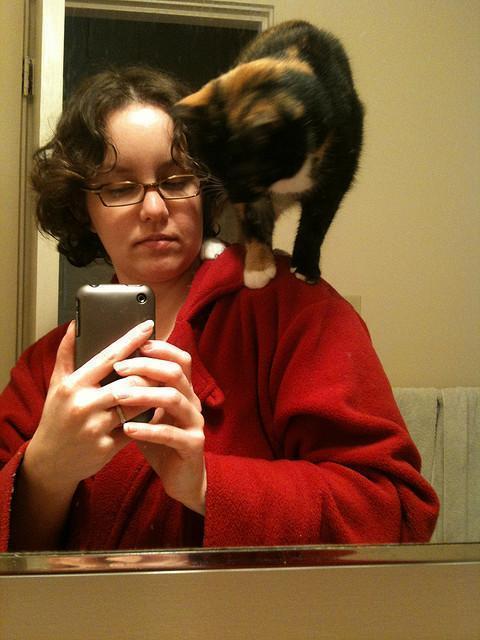What bathroom fixture is located in front of the woman at waist height?
Indicate the correct response by choosing from the four available options to answer the question.
Options: Sink, hamper, toilet, towel rack. Sink. 